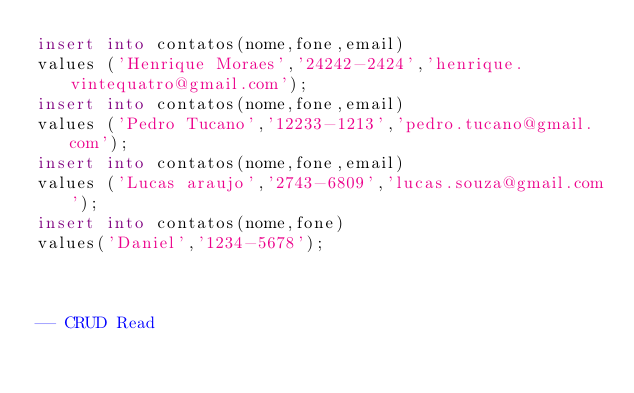Convert code to text. <code><loc_0><loc_0><loc_500><loc_500><_SQL_>insert into contatos(nome,fone,email)
values ('Henrique Moraes','24242-2424','henrique.vintequatro@gmail.com');
insert into contatos(nome,fone,email)
values ('Pedro Tucano','12233-1213','pedro.tucano@gmail.com');
insert into contatos(nome,fone,email)
values ('Lucas araujo','2743-6809','lucas.souza@gmail.com');
insert into contatos(nome,fone) 
values('Daniel','1234-5678');

 

-- CRUD Read</code> 